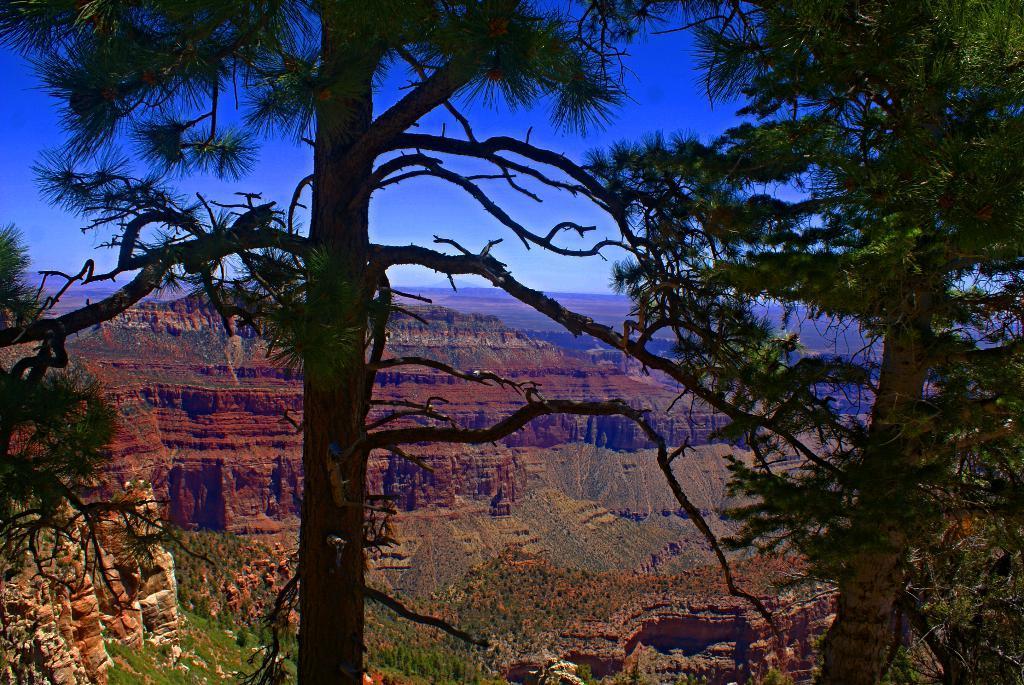In one or two sentences, can you explain what this image depicts? In this image we can see the trees and also the hills. In the background we can see the sky. 